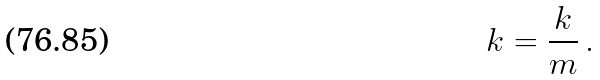Convert formula to latex. <formula><loc_0><loc_0><loc_500><loc_500>\ k = \frac { k } { m } \, .</formula> 